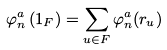<formula> <loc_0><loc_0><loc_500><loc_500>\varphi ^ { a } _ { n } \left ( 1 _ { F } \right ) = \sum _ { u \in F } \varphi ^ { a } _ { n } ( r _ { u } )</formula> 